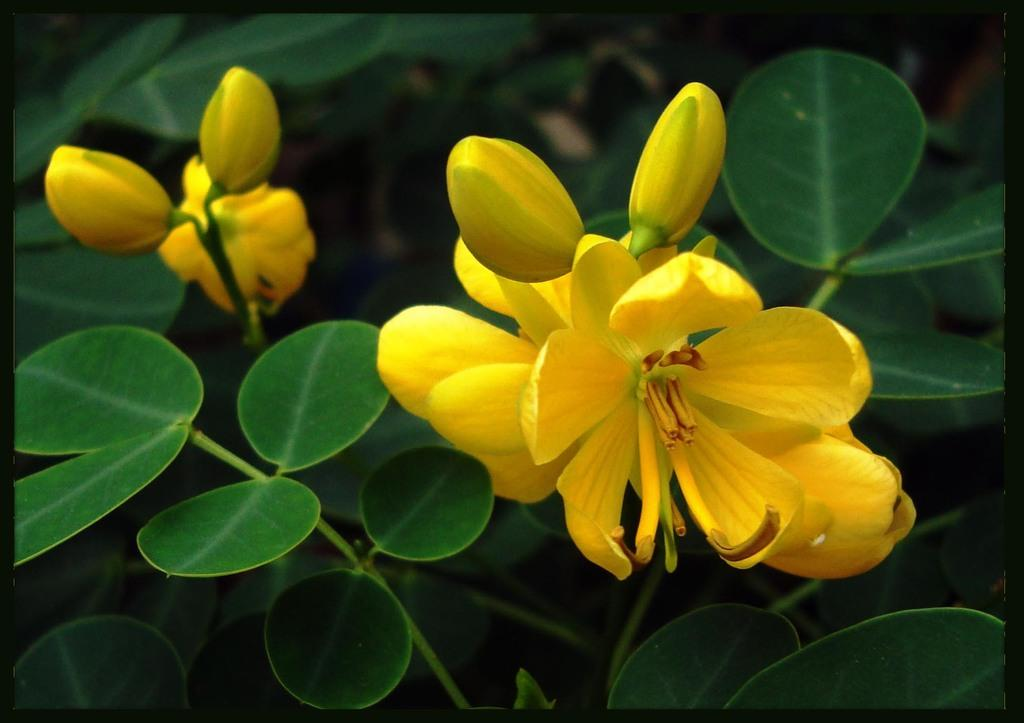What type of living organisms are present in the image? There are plants in the image. What specific features can be observed on the plants? The plants have flowers and buds. What color are the flowers and buds? The flowers and buds are in yellow color. Where is the sofa located in the image? There is no sofa present in the image. Can you describe the garden in the image? There is no garden present in the image; it features plants with flowers and buds. 